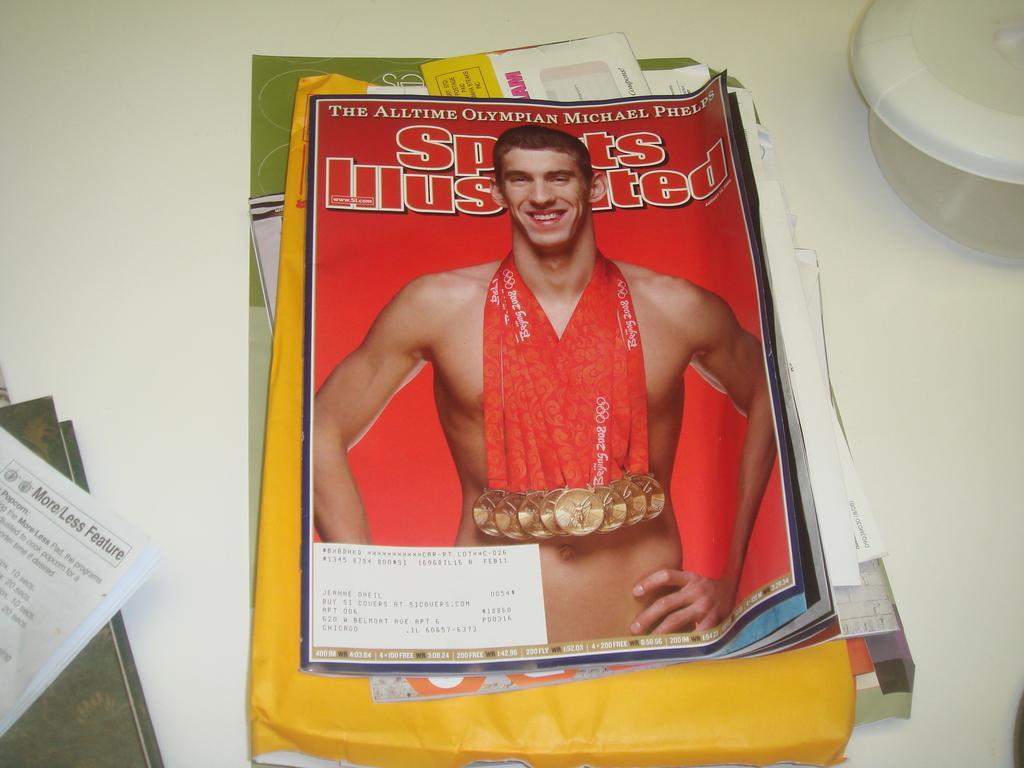Could you give a brief overview of what you see in this image? In this image there is a magazine, papers and objects are on the white surface. Something is written in the magazine and papers.   